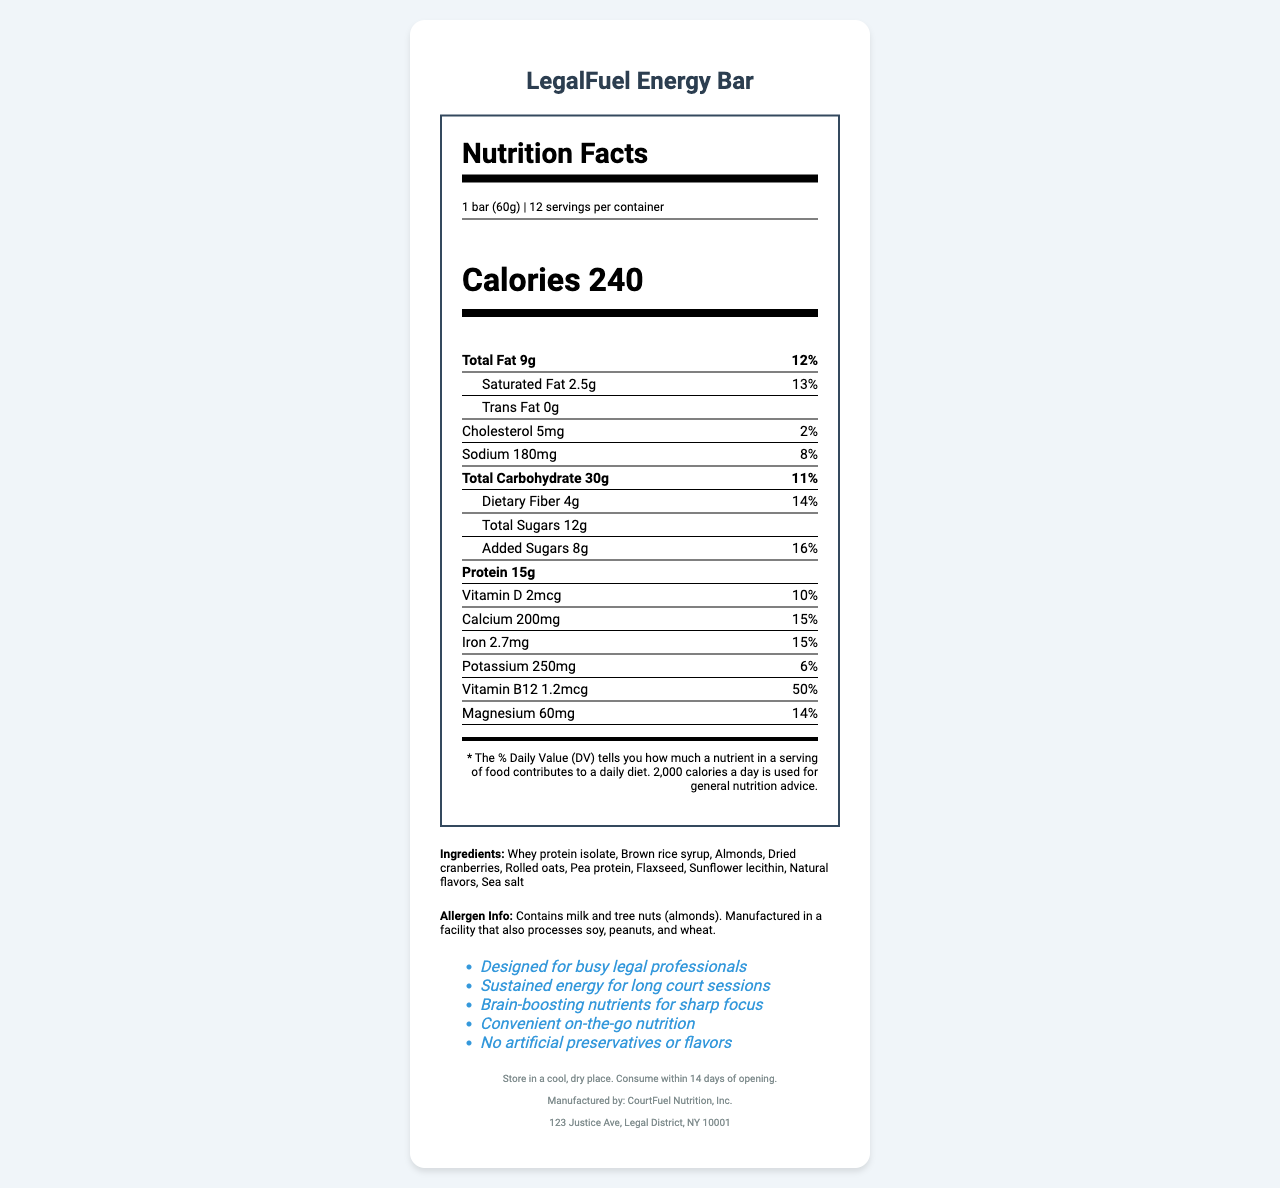How many calories are in one LegalFuel Energy Bar? The document states that there are 240 calories per bar.
Answer: 240 What is the serving size for the LegalFuel Energy Bar? The serving size is stated to be 1 bar weighing 60g.
Answer: 1 bar (60g) How many servings are there per container of LegalFuel Energy Bars? The document notes that there are 12 servings per container.
Answer: 12 What is the total fat content in one LegalFuel Energy Bar? The total fat content listed is 9g.
Answer: 9g What are the primary ingredients in the LegalFuel Energy Bar? The ingredients list includes these primary items.
Answer: Whey protein isolate, Brown rice syrup, Almonds, Dried cranberries, Rolled oats, Pea protein, Flaxseed, Sunflower lecithin, Natural flavors, Sea salt What is the amount of dietary fiber in one bar? The dietary fiber content is listed as 4g.
Answer: 4g What percentage of the daily value of Vitamin B12 is provided in one bar? It provides 50% of the daily value of Vitamin B12.
Answer: 50% What is the manufacturer of LegalFuel Energy Bar, and where are they located? The manufacturer and location are specified as CourtFuel Nutrition, Inc., located at 123 Justice Ave, Legal District, NY 10001.
Answer: CourtFuel Nutrition, Inc., 123 Justice Ave, Legal District, NY 10001 Which of the following nutrients has the highest percentage of daily value? A. Vitamin D B. Iron C. Calcium D. Vitamin B12 Vitamin B12 has the highest percentage of daily value at 50%, compared to Vitamin D at 10%, Iron and Calcium both at 15%.
Answer: D. Vitamin B12 Which of the following marketing claims is NOT stated in the document? A. Designed for busy legal professionals B. Contains antioxidants for better health C. Brain-boosting nutrients for sharp focus D. No artificial preservatives or flavors The document does not mention "Contains antioxidants for better health" as a marketing claim.
Answer: B. Contains antioxidants for better health Does the LegalFuel Energy Bar contain any artificial preservatives or flavors? The marketing claims clearly state "No artificial preservatives or flavors."
Answer: No Summarize the document about the LegalFuel Energy Bar. The summary encapsulates the key points listed in the document, including nutritional values, ingredients, allergen info, marketing claims, and storage instructions.
Answer: The document provides comprehensive nutritional information about the LegalFuel Energy Bar, designed for busy legal professionals. Each bar contains 240 calories, with specific amounts of fats, carbohydrates, and proteins, and various vitamins and minerals. The document also lists the ingredients, allergen information, and marketing claims emphasizing its benefits for sustained energy and sharp focus. Storage instructions and manufacturer details are also provided. What is the exact amount of Omega-3 fatty acids in one LegalFuel Energy Bar? The document does not provide information on the Omega-3 fatty acid content.
Answer: Not enough information 